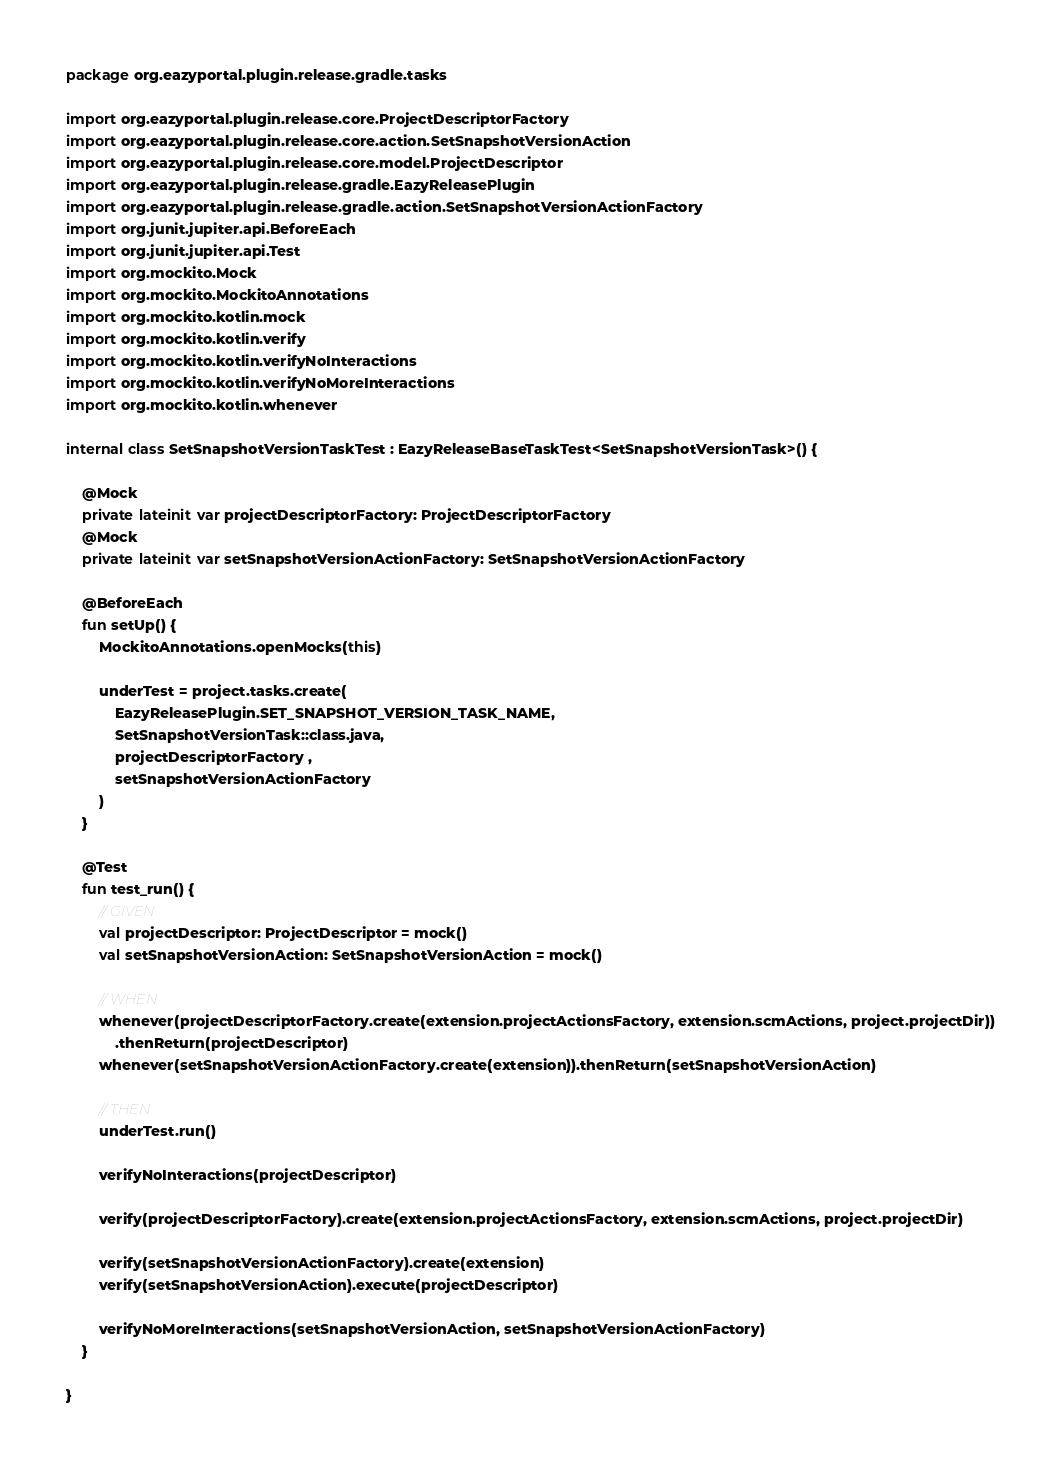<code> <loc_0><loc_0><loc_500><loc_500><_Kotlin_>package org.eazyportal.plugin.release.gradle.tasks

import org.eazyportal.plugin.release.core.ProjectDescriptorFactory
import org.eazyportal.plugin.release.core.action.SetSnapshotVersionAction
import org.eazyportal.plugin.release.core.model.ProjectDescriptor
import org.eazyportal.plugin.release.gradle.EazyReleasePlugin
import org.eazyportal.plugin.release.gradle.action.SetSnapshotVersionActionFactory
import org.junit.jupiter.api.BeforeEach
import org.junit.jupiter.api.Test
import org.mockito.Mock
import org.mockito.MockitoAnnotations
import org.mockito.kotlin.mock
import org.mockito.kotlin.verify
import org.mockito.kotlin.verifyNoInteractions
import org.mockito.kotlin.verifyNoMoreInteractions
import org.mockito.kotlin.whenever

internal class SetSnapshotVersionTaskTest : EazyReleaseBaseTaskTest<SetSnapshotVersionTask>() {

    @Mock
    private lateinit var projectDescriptorFactory: ProjectDescriptorFactory
    @Mock
    private lateinit var setSnapshotVersionActionFactory: SetSnapshotVersionActionFactory

    @BeforeEach
    fun setUp() {
        MockitoAnnotations.openMocks(this)

        underTest = project.tasks.create(
            EazyReleasePlugin.SET_SNAPSHOT_VERSION_TASK_NAME,
            SetSnapshotVersionTask::class.java,
            projectDescriptorFactory ,
            setSnapshotVersionActionFactory
        )
    }

    @Test
    fun test_run() {
        // GIVEN
        val projectDescriptor: ProjectDescriptor = mock()
        val setSnapshotVersionAction: SetSnapshotVersionAction = mock()

        // WHEN
        whenever(projectDescriptorFactory.create(extension.projectActionsFactory, extension.scmActions, project.projectDir))
            .thenReturn(projectDescriptor)
        whenever(setSnapshotVersionActionFactory.create(extension)).thenReturn(setSnapshotVersionAction)

        // THEN
        underTest.run()

        verifyNoInteractions(projectDescriptor)

        verify(projectDescriptorFactory).create(extension.projectActionsFactory, extension.scmActions, project.projectDir)

        verify(setSnapshotVersionActionFactory).create(extension)
        verify(setSnapshotVersionAction).execute(projectDescriptor)

        verifyNoMoreInteractions(setSnapshotVersionAction, setSnapshotVersionActionFactory)
    }

}
</code> 